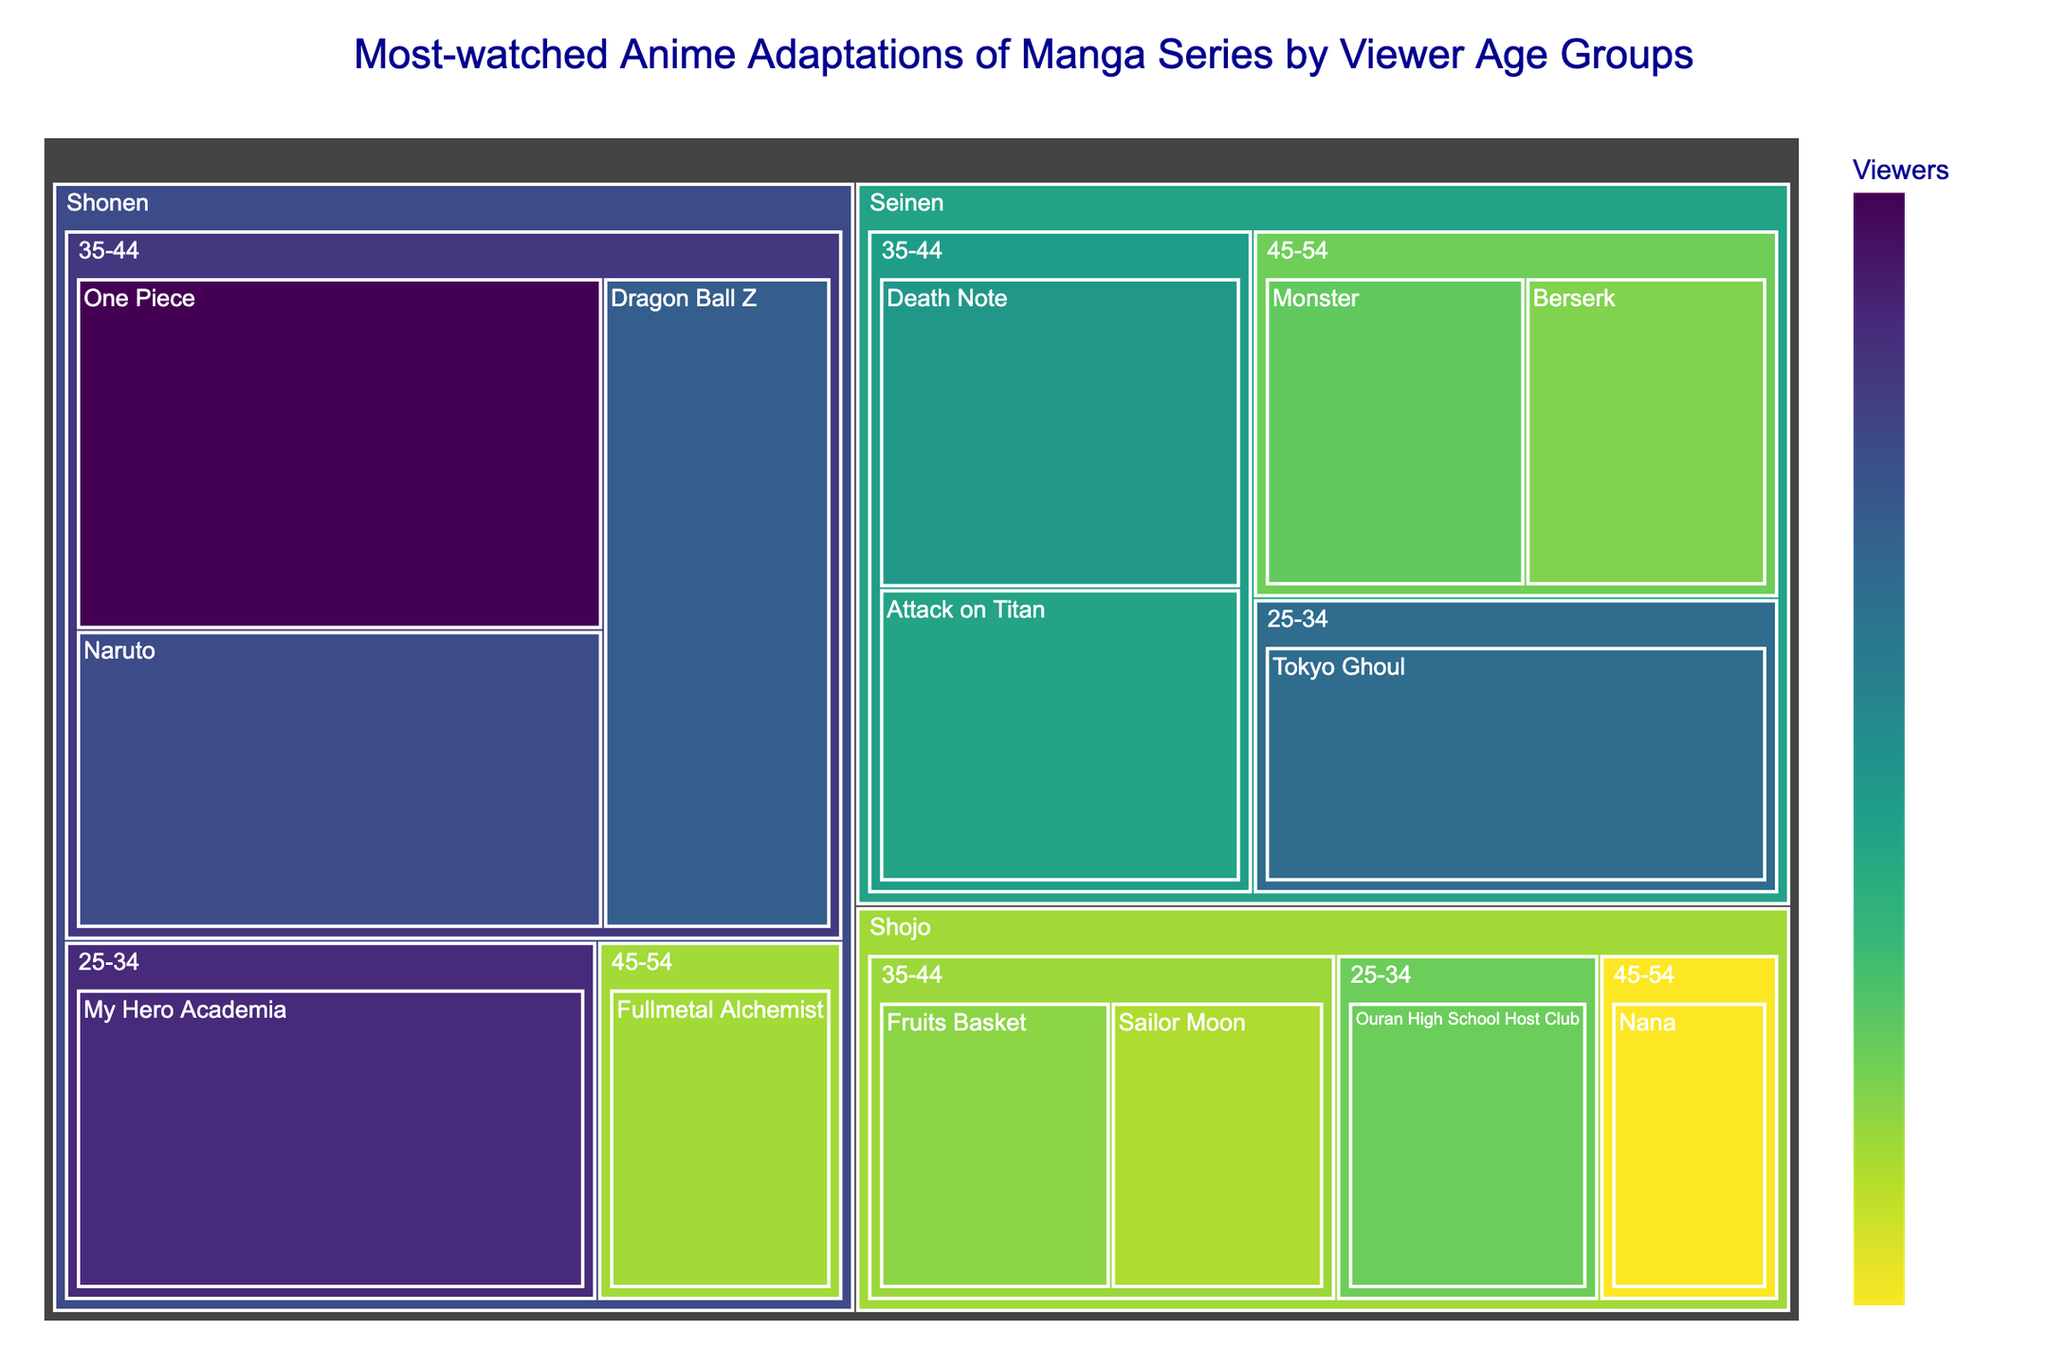what is the title of the treemap? The title is displayed at the top of the figure, providing a summary of what the data represents. By reading it, you can understand that the figure shows the "Most-watched Anime Adaptations of Manga Series by Viewer Age Groups"
Answer: Most-watched Anime Adaptations of Manga Series by Viewer Age Groups Which anime series has the highest number of viewers in the 35-44 age group? Look for the largest block within the "35-44" age group. The series with the largest block is "One Piece" with 8,500,000 viewers
Answer: One Piece How many viewers watched "Fruits Basket" in the 35-44 age group? Locate the "Fruits Basket" block within the "35-44" age group. By hovering over the block, the number of viewers will be displayed as 3,800,000
Answer: 3,800,000 What is the combined number of viewers for "Shonen" category in the 35-44 age group? Sum the viewers for all Shonen series in the 35-44 age group: One Piece (8,500,000) + Naruto (7,200,000) + Dragon Ball Z (6,800,000). The total is 22,500,000
Answer: 22,500,000 Which category has the most viewers in the 25-34 age group? Identify the categories within the 25-34 age group and compare their viewer counts. "Shonen" has 7,800,000 (My Hero Academia), which is the highest among the categories.
Answer: Shonen Is "Attack on Titan" more popular among 35-44 or 25-34 age group? Locate "Attack on Titan" in both age groups and compare their viewer numbers. "Attack on Titan" is only present in the 35-44 age group with 5,200,000 viewers and not in the 25-34 group.
Answer: 35-44 Which has more viewers: "Death Note" in 35-44 age group or "Tokyo Ghoul" in 25-34 age group? Compare the viewer counts: "Death Note" (5,500,000) and "Tokyo Ghoul" (6,500,000). Tokyo Ghoul has more viewers.
Answer: Tokyo Ghoul How many viewers are there in total for the "Seinen" category across all age groups? Sum the viewers for all Seinen series: Death Note (5,500,000) + Attack on Titan (5,200,000) + Monster (4,200,000) + Berserk (3,900,000) + Tokyo Ghoul (6,500,000). Total: 25,300,000
Answer: 25,300,000 Which Seinen series in the 45-54 age group has more viewers: "Monster" or "Berserk"? Identify the viewer counts for both series in the 45-54 age group. "Monster" has 4,200,000 viewers while "Berserk" has 3,900,000. "Monster" has more viewers.
Answer: Monster 